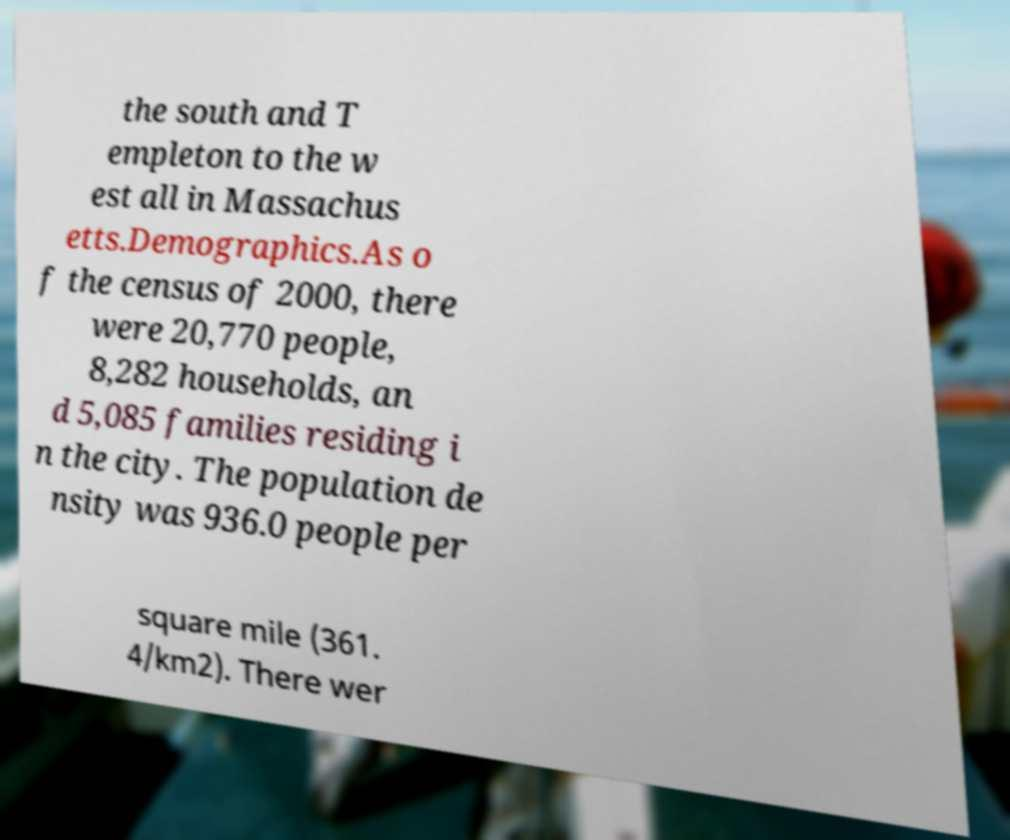Please read and relay the text visible in this image. What does it say? the south and T empleton to the w est all in Massachus etts.Demographics.As o f the census of 2000, there were 20,770 people, 8,282 households, an d 5,085 families residing i n the city. The population de nsity was 936.0 people per square mile (361. 4/km2). There wer 